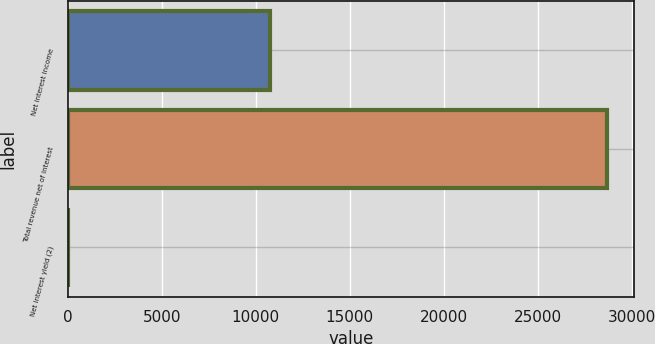Convert chart to OTSL. <chart><loc_0><loc_0><loc_500><loc_500><bar_chart><fcel>Net interest income<fcel>Total revenue net of interest<fcel>Net interest yield (2)<nl><fcel>10739<fcel>28702<fcel>2.32<nl></chart> 